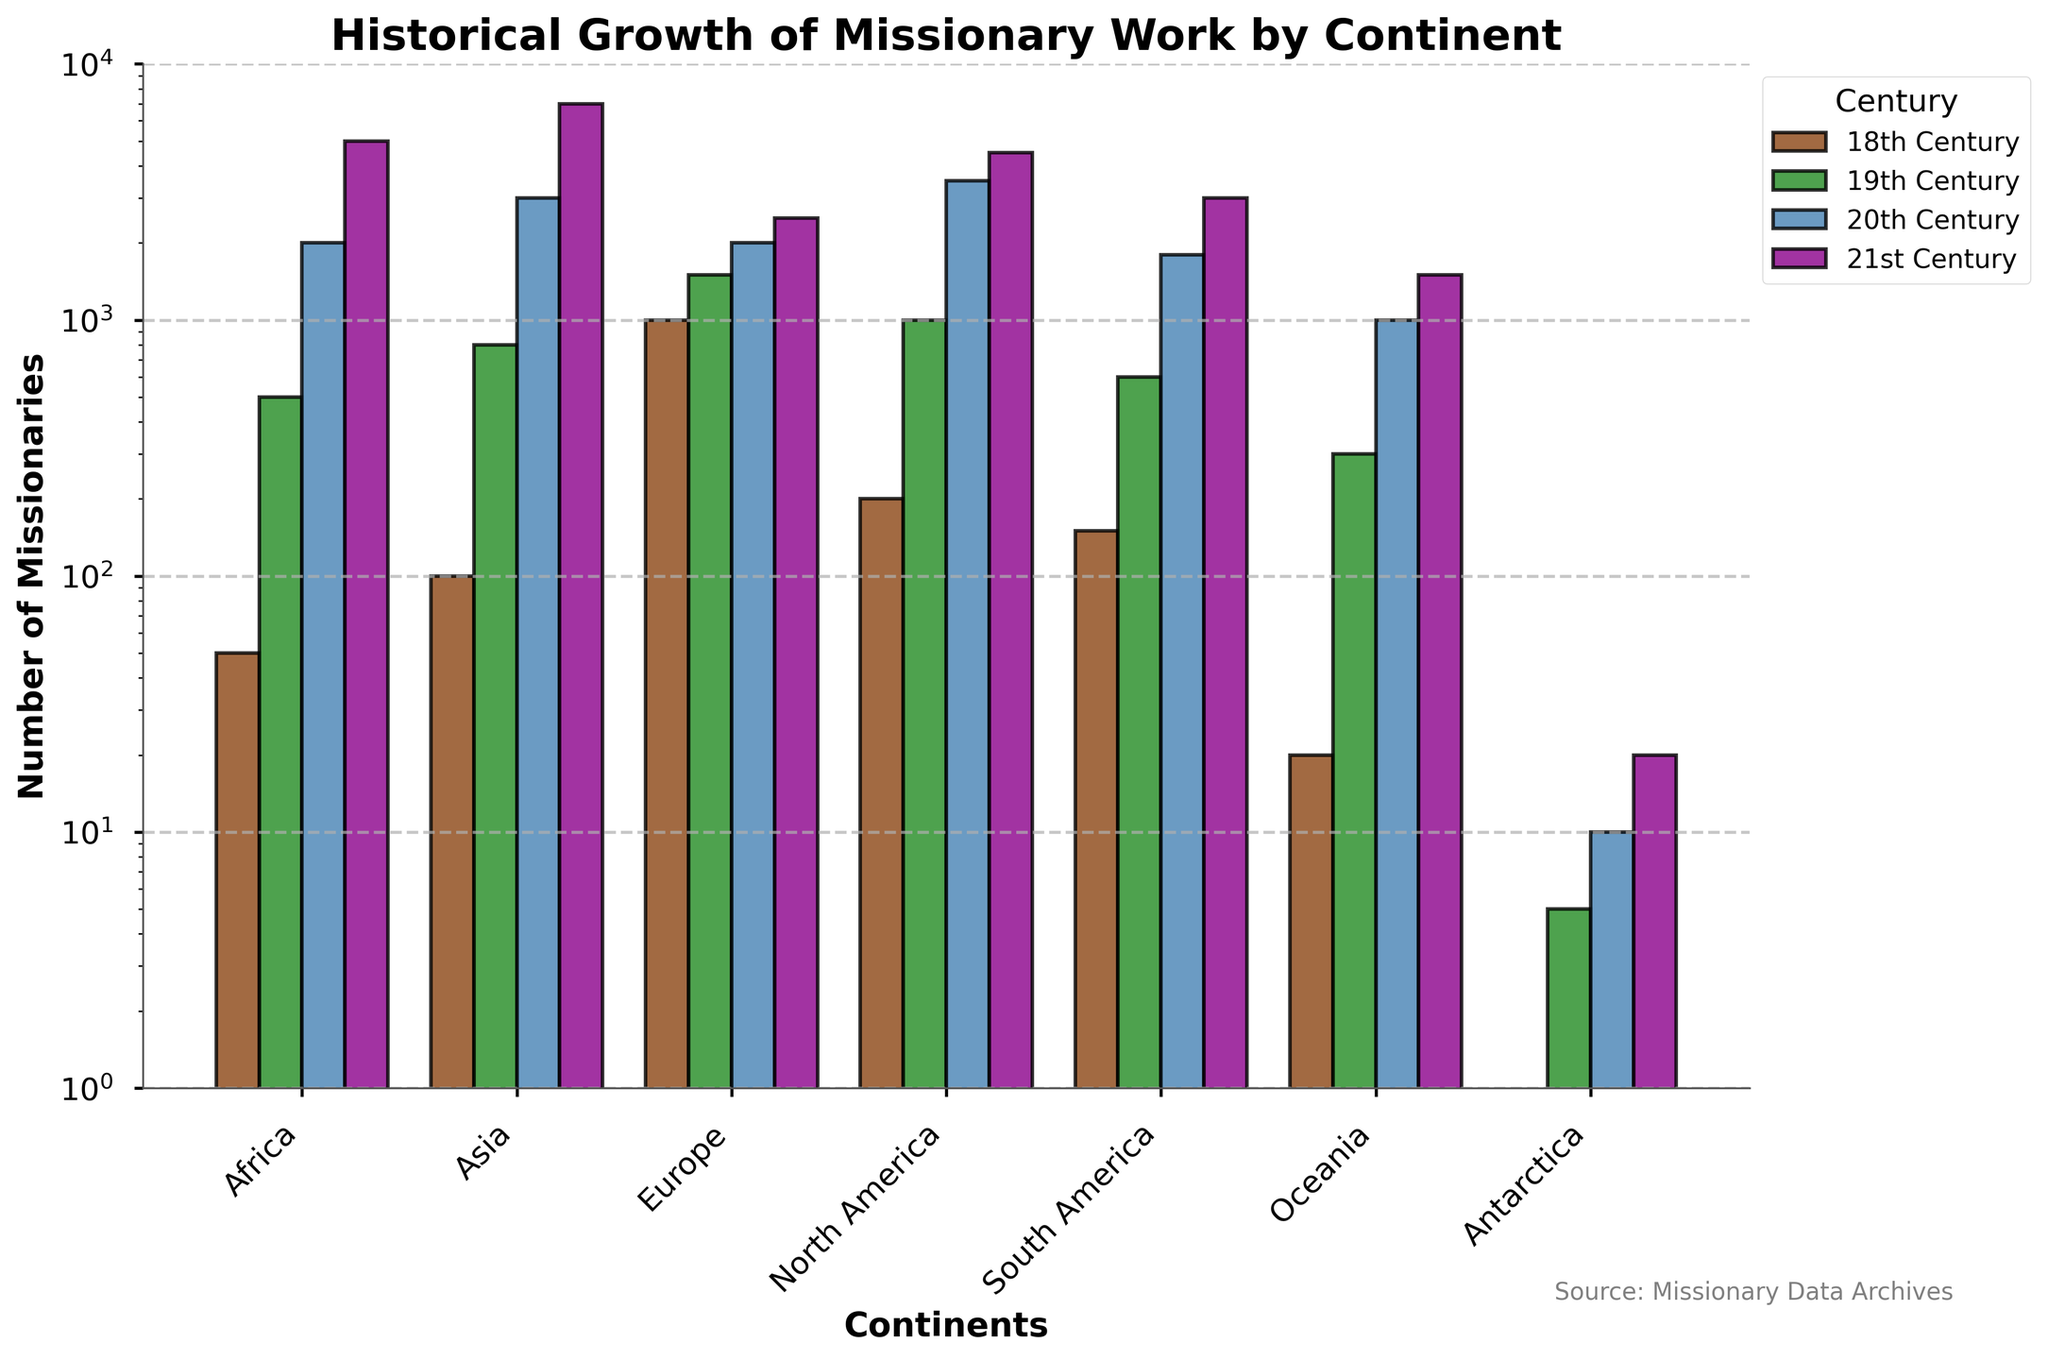What's the difference in the number of missionaries in Africa between the 21st century and the 18th century? First, identify the number of missionaries in Africa for the 21st century (5000) and the 18th century (50) from the bar chart. Then, subtract the number in the 18th century from the number in the 21st century: 5000 - 50 = 4950
Answer: 4950 Which continent had the highest increase in missionary counts from the 19th century to the 20th century? Observe the heights of the bars for each continent for the 19th and 20th centuries. Calculate the increase for each continent: Africa (2000-500=1500), Asia (3000-800=2200), Europe (2000-1500=500), North America (3500-1000=2500), South America (1800-600=1200), Oceania (1000-300=700), Antarctica (10-5=5). The highest increase is in Asia: 3000 - 800 = 2200
Answer: Asia Which century has the largest number of missionaries in North America? Compare the heights of the bars representing North America across all centuries. The bar for the 20th century is at 3500, while the 21st century is at 4500, being the highest among them.
Answer: 21st century What is the total number of missionaries across all continents in the 19th century? Sum the values from the 19th-century bars for all continents: Africa (500) + Asia (800) + Europe (1500) + North America (1000) + South America (600) + Oceania (300) + Antarctica (5). The total is: 500 + 800 + 1500 + 1000 + 600 + 300 + 5 = 4705
Answer: 4705 By how much did missionary work in South America grow from the 20th century to the 21st century? Find the number of missionaries in South America in the 20th century (1800) and the 21st century (3000). Subtract the 20th-century value from the 21st-century value: 3000 - 1800 = 1200
Answer: 1200 Which continent had the smallest change in the number of missionaries between the 18th and 19th centuries? Compare the changes in the number of missionaries between these two centuries for each continent. The differences: Africa (450), Asia (700), Europe (500), North America (800), South America (450), Oceania (280), Antarctica (5). The smallest change is in Antarctica: 5 - 0 = 5
Answer: Antarctica What is the average number of missionaries in Europe across the entire timeline? Find the values for Europe in each century: 18th (1000), 19th (1500), 20th (2000), 21st (2500). Sum them: 1000 + 1500 + 2000 + 2500 = 7000. Divide by the number of centuries (4): 7000 / 4 = 1750
Answer: 1750 How does the number of missionaries in Oceania in the 20th century compare to those in the 19th century? Find the number of missionaries in Oceania for the 19th century (300) and 20th century (1000). Compare these values: 1000 > 300
Answer: 1000 > 300 What color represents the 21st century in the bar chart? Look at the legend to identify the color associated with the 21st century. It is shown in purple.
Answer: Purple 